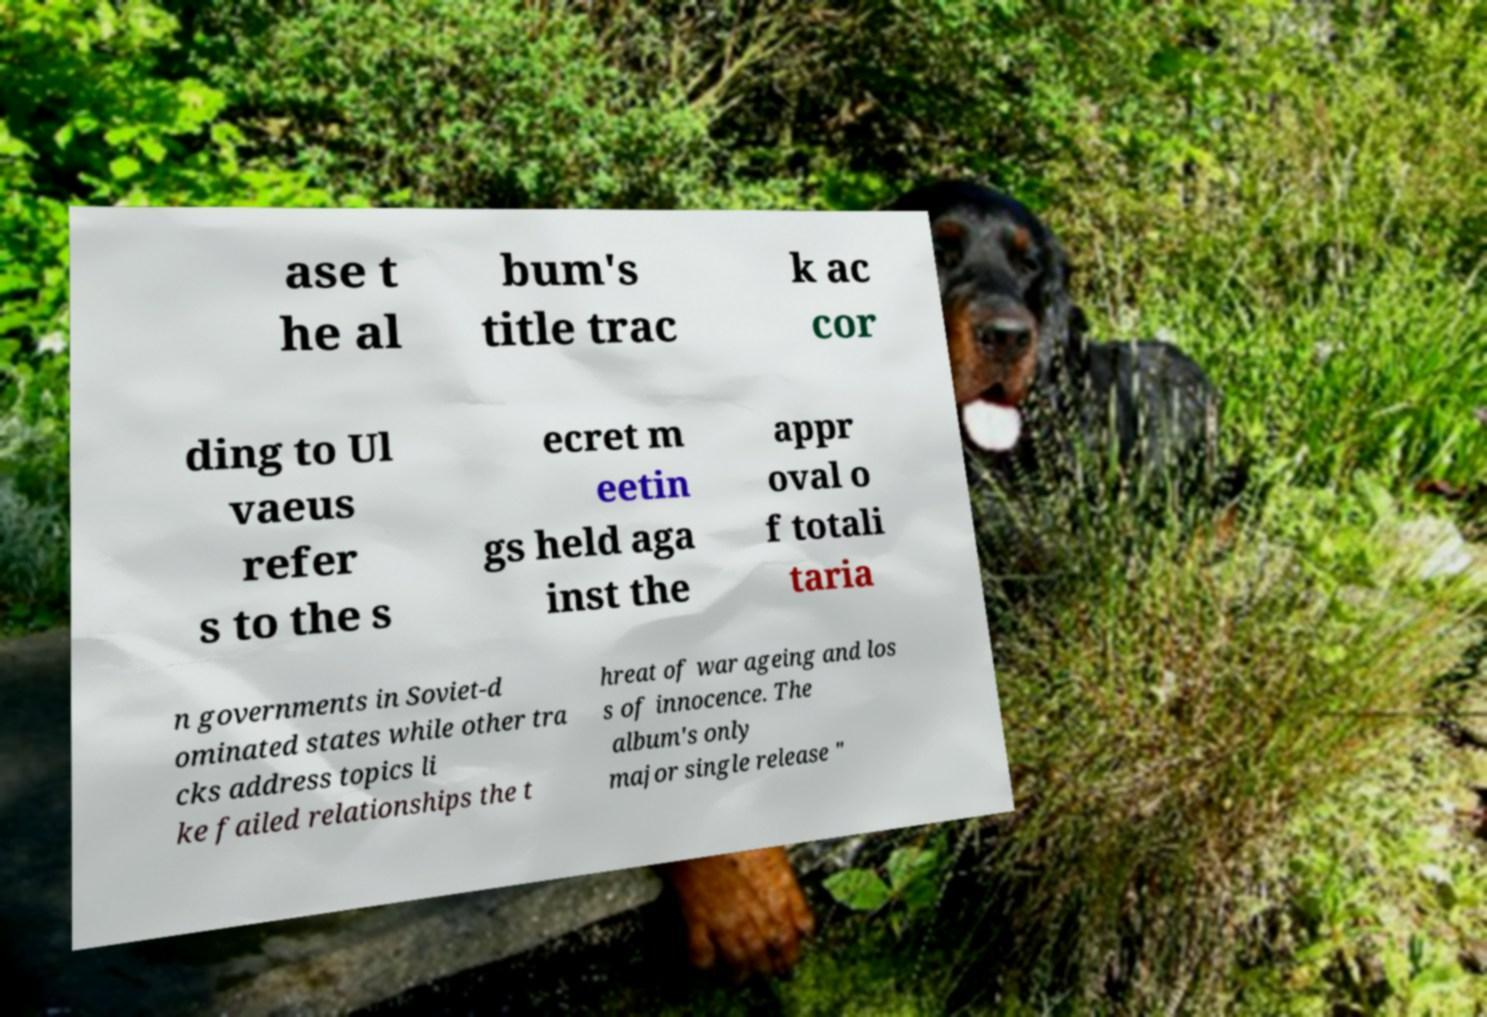Could you extract and type out the text from this image? ase t he al bum's title trac k ac cor ding to Ul vaeus refer s to the s ecret m eetin gs held aga inst the appr oval o f totali taria n governments in Soviet-d ominated states while other tra cks address topics li ke failed relationships the t hreat of war ageing and los s of innocence. The album's only major single release " 